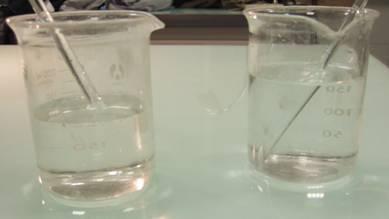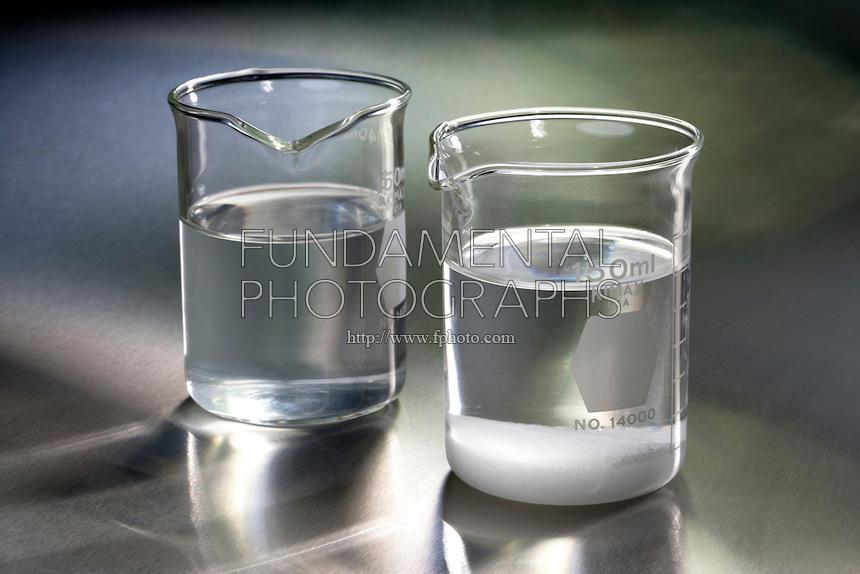The first image is the image on the left, the second image is the image on the right. Examine the images to the left and right. Is the description "There are four beakers in total." accurate? Answer yes or no. Yes. The first image is the image on the left, the second image is the image on the right. Given the left and right images, does the statement "There are four measuring glasses." hold true? Answer yes or no. Yes. 